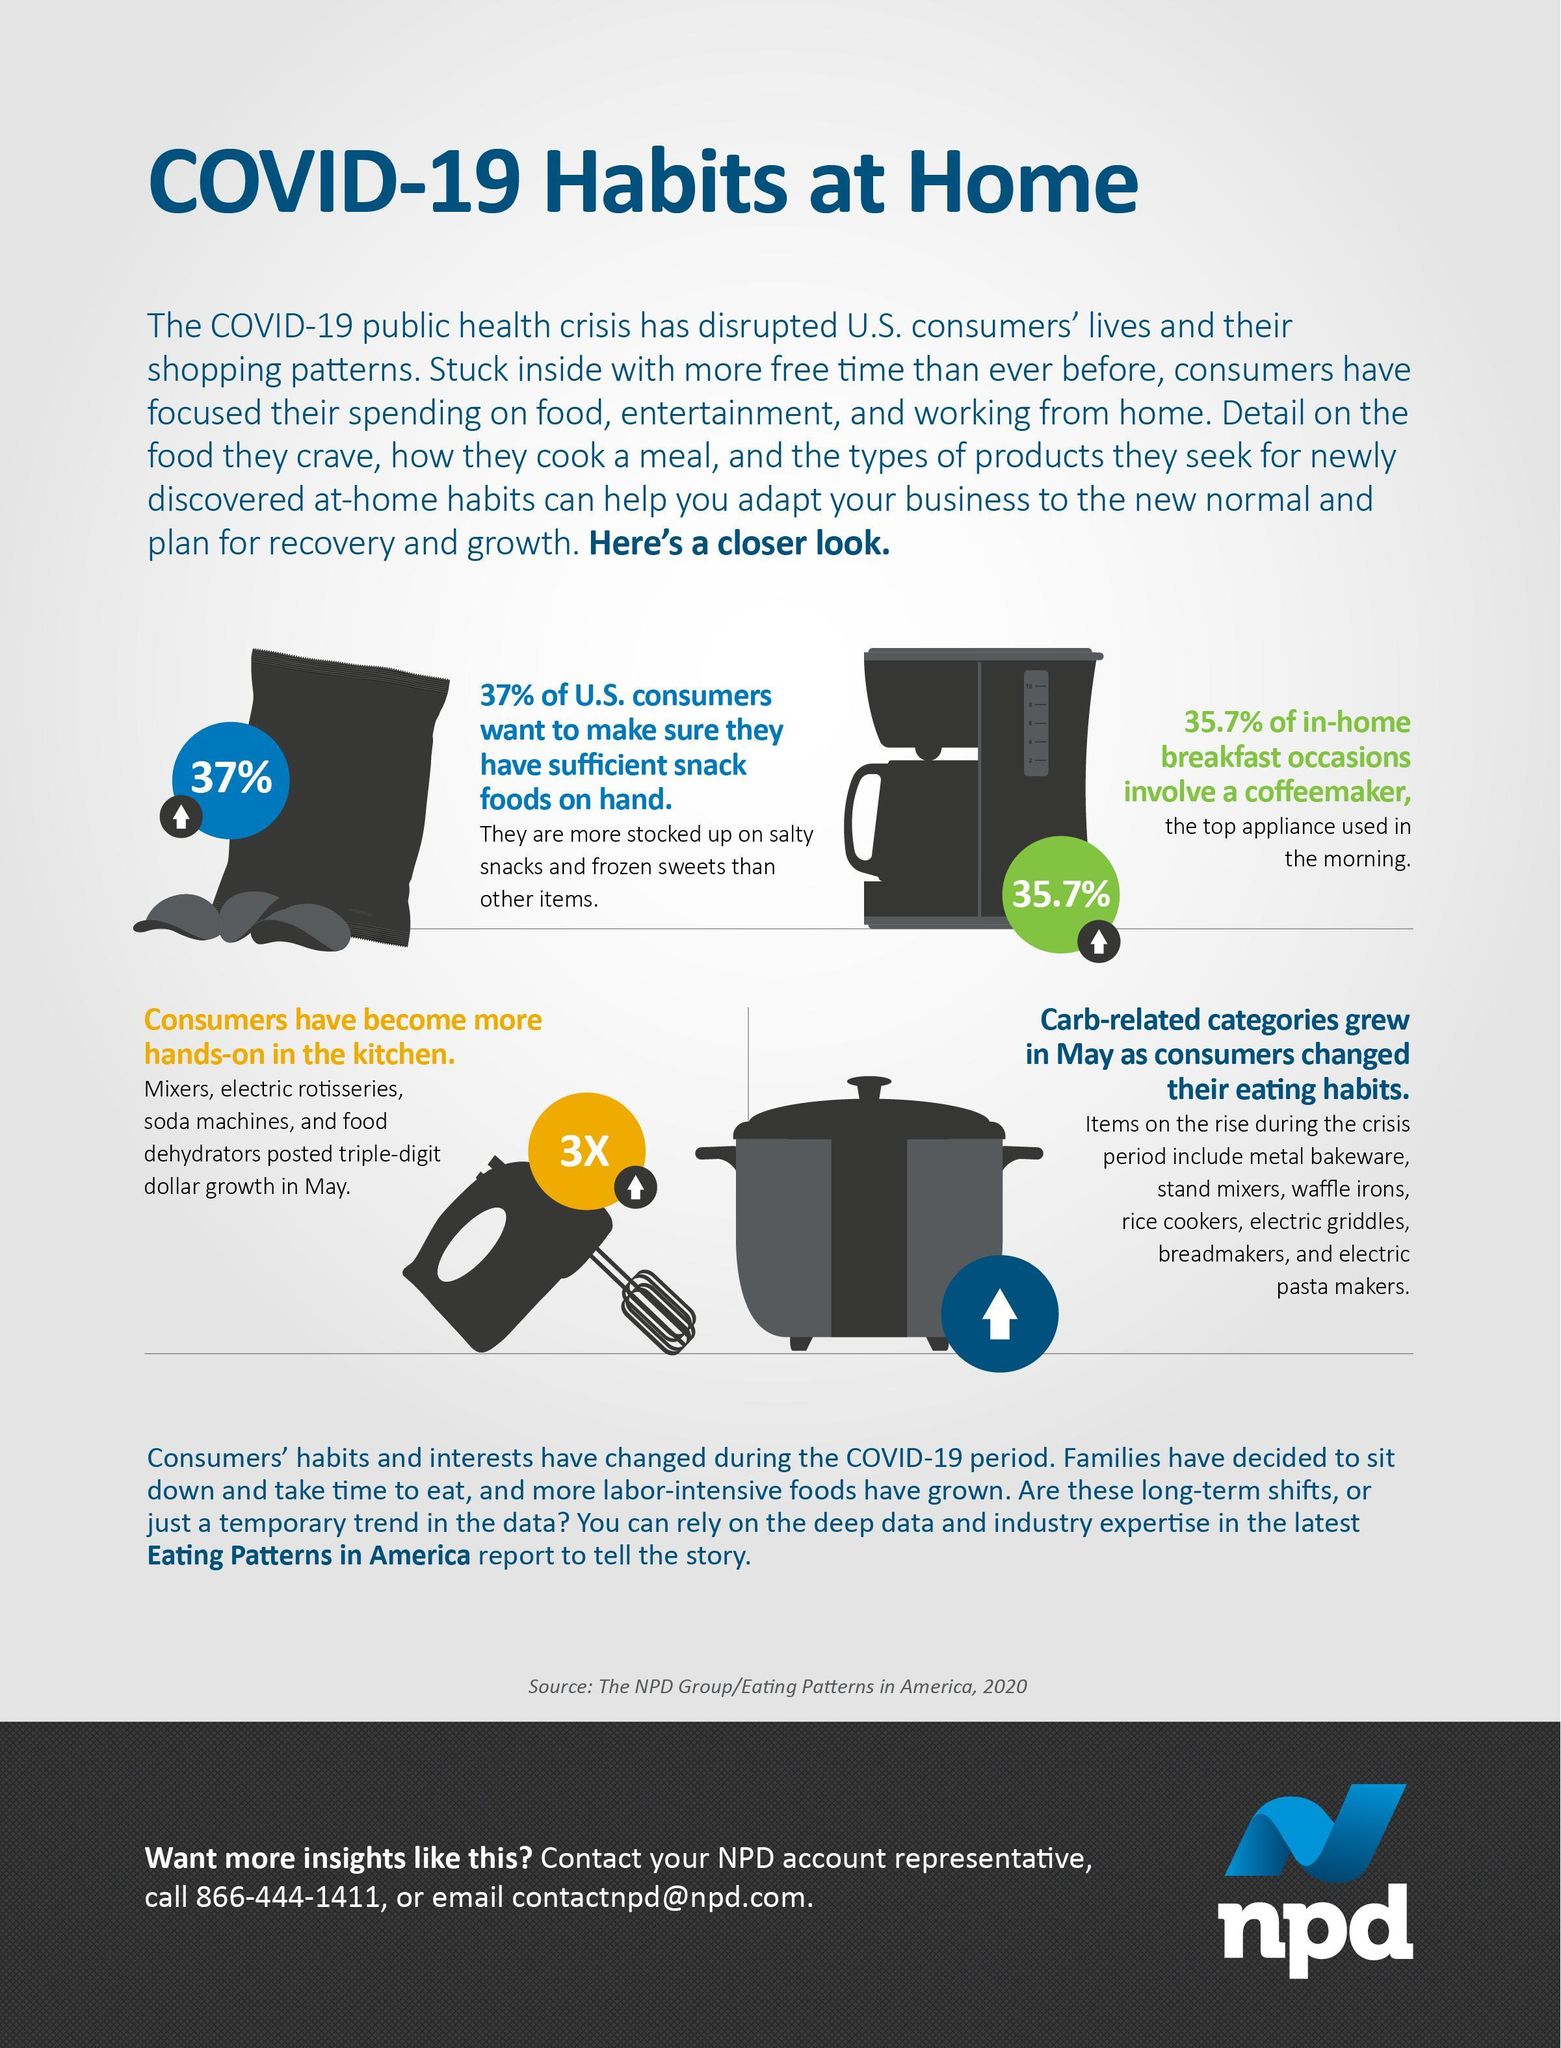what is the percentage of in-home breakfast occasions that does not involve a coffeemaker?
Answer the question with a short phrase. 64.3 total count of the word "COVID-19" in this infographic is? 3 percentage increase in coffeemaker has shown in which color circle - green or blue? green what percent of US consumers does not want to make sure the have sufficient food on hand? 63 What percent of U. S. consumers did stock up snacks and foods? 37% 